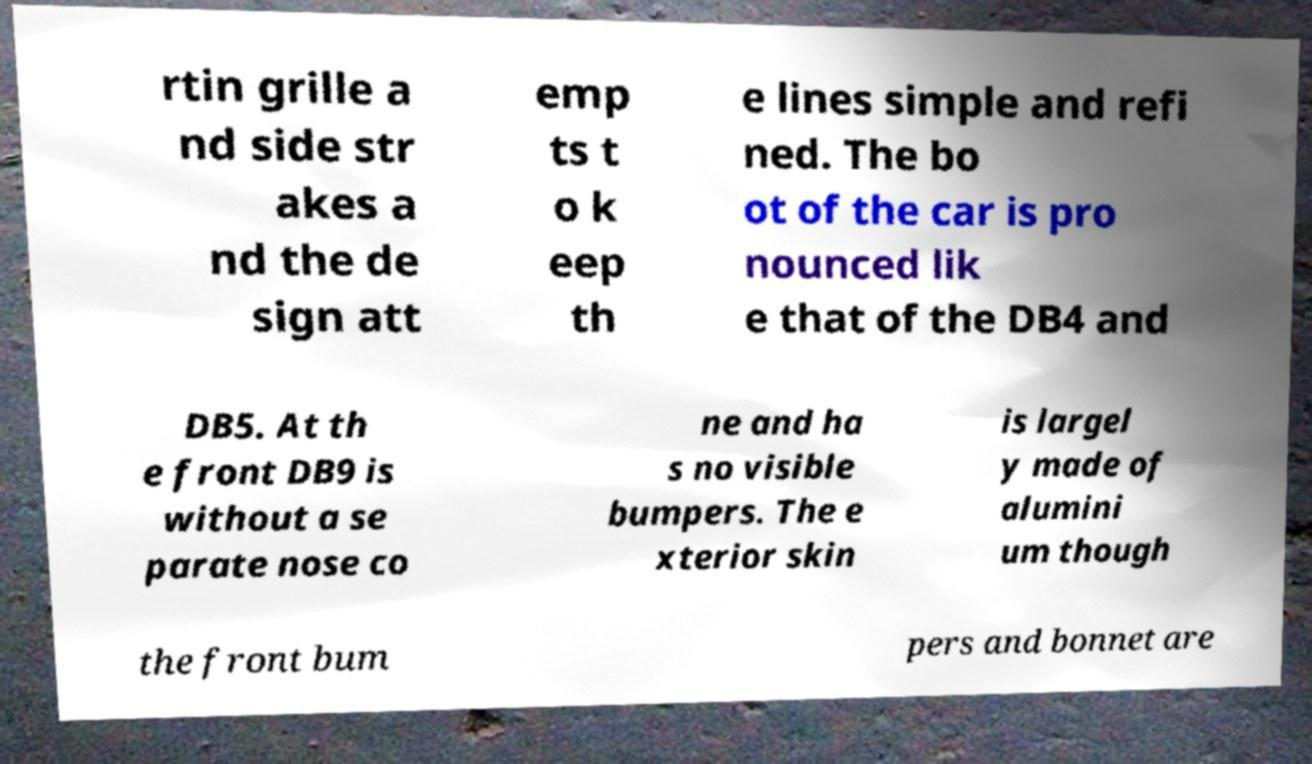Could you assist in decoding the text presented in this image and type it out clearly? rtin grille a nd side str akes a nd the de sign att emp ts t o k eep th e lines simple and refi ned. The bo ot of the car is pro nounced lik e that of the DB4 and DB5. At th e front DB9 is without a se parate nose co ne and ha s no visible bumpers. The e xterior skin is largel y made of alumini um though the front bum pers and bonnet are 